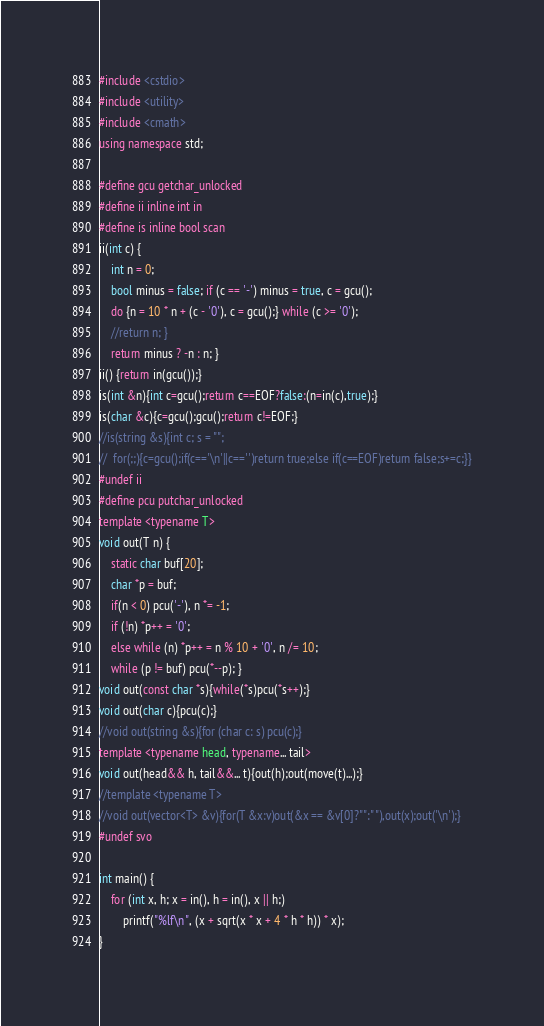<code> <loc_0><loc_0><loc_500><loc_500><_C++_>#include <cstdio>
#include <utility>
#include <cmath>
using namespace std;

#define gcu getchar_unlocked
#define ii inline int in
#define is inline bool scan
ii(int c) {
	int n = 0;
	bool minus = false; if (c == '-') minus = true, c = gcu();
	do {n = 10 * n + (c - '0'), c = gcu();} while (c >= '0');
	//return n; }
	return minus ? -n : n; }
ii() {return in(gcu());}
is(int &n){int c=gcu();return c==EOF?false:(n=in(c),true);}
is(char &c){c=gcu();gcu();return c!=EOF;}
//is(string &s){int c; s = "";
//	for(;;){c=gcu();if(c=='\n'||c==' ')return true;else if(c==EOF)return false;s+=c;}}
#undef ii
#define pcu putchar_unlocked
template <typename T>
void out(T n) {
	static char buf[20];
	char *p = buf;
	if(n < 0) pcu('-'), n *= -1;
	if (!n) *p++ = '0';
	else while (n) *p++ = n % 10 + '0', n /= 10;
	while (p != buf) pcu(*--p); }
void out(const char *s){while(*s)pcu(*s++);}
void out(char c){pcu(c);}
//void out(string &s){for (char c: s) pcu(c);}
template <typename head, typename... tail>
void out(head&& h, tail&&... t){out(h);out(move(t)...);}
//template <typename T>
//void out(vector<T> &v){for(T &x:v)out(&x == &v[0]?"":" "),out(x);out('\n');}
#undef svo

int main() {
	for (int x, h; x = in(), h = in(), x || h;)
		printf("%lf\n", (x + sqrt(x * x + 4 * h * h)) * x);
}
</code> 